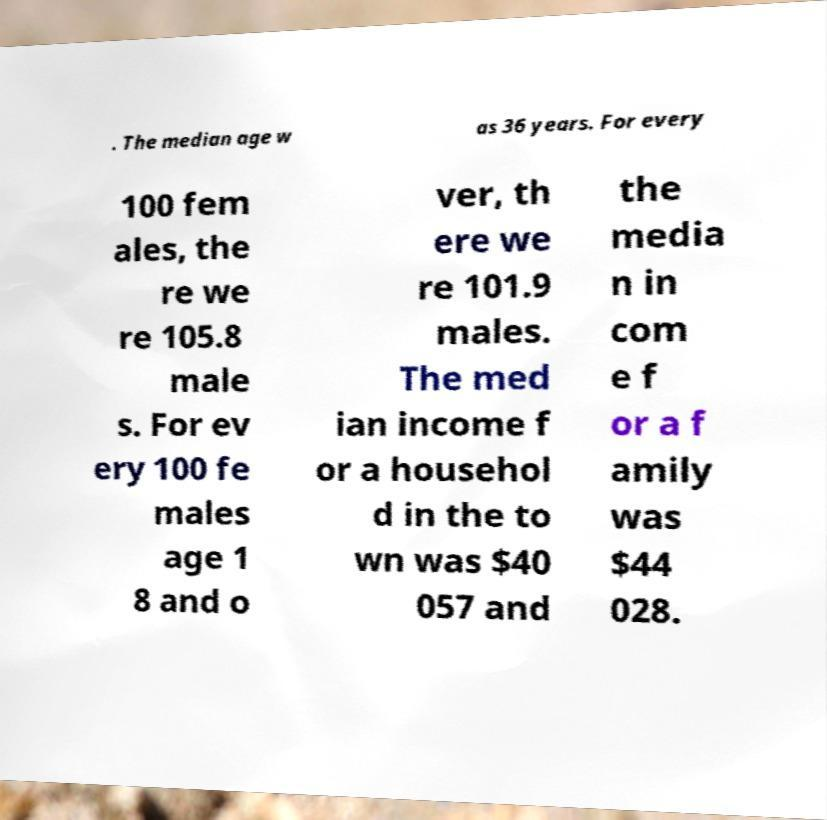Please identify and transcribe the text found in this image. . The median age w as 36 years. For every 100 fem ales, the re we re 105.8 male s. For ev ery 100 fe males age 1 8 and o ver, th ere we re 101.9 males. The med ian income f or a househol d in the to wn was $40 057 and the media n in com e f or a f amily was $44 028. 